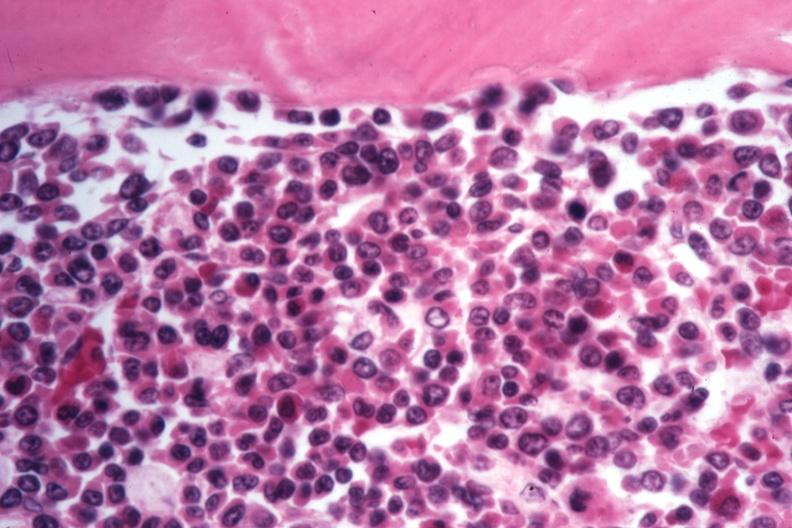does this cells appear to be moving to blast crisis?
Answer the question using a single word or phrase. Yes 